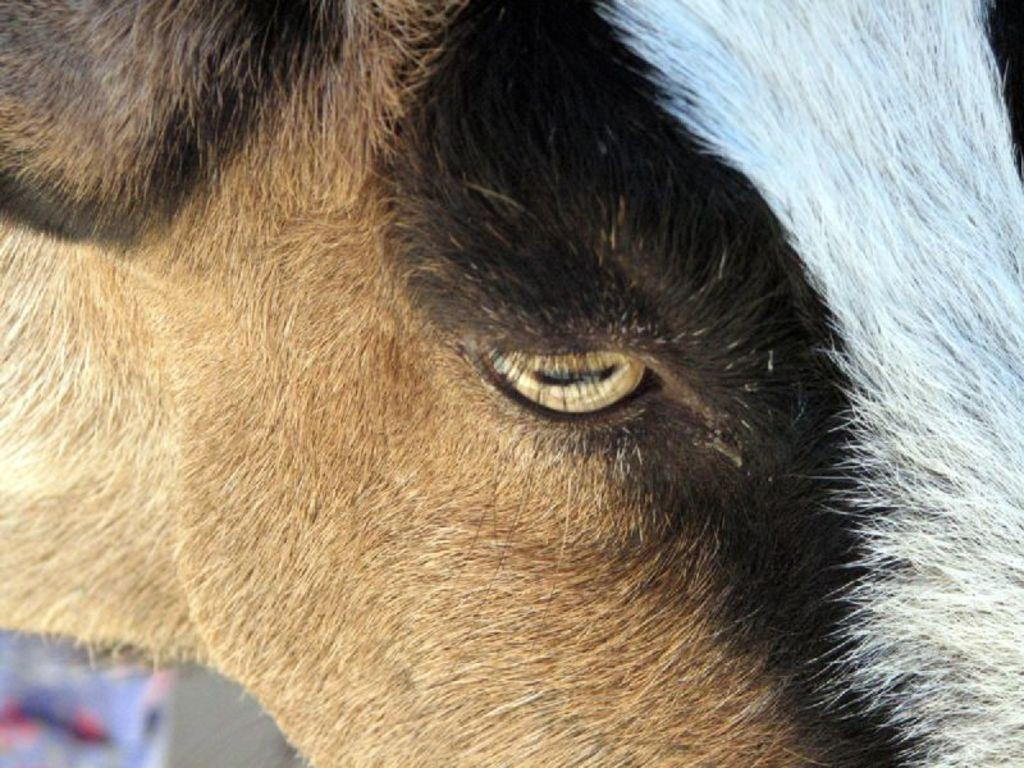What is the main subject of the image? There is an animal in the center of the image. What time of day is it in the image, according to the hour displayed on the animal? There is no hour displayed on the animal in the image, as it is not a clock or any other timekeeping device. 